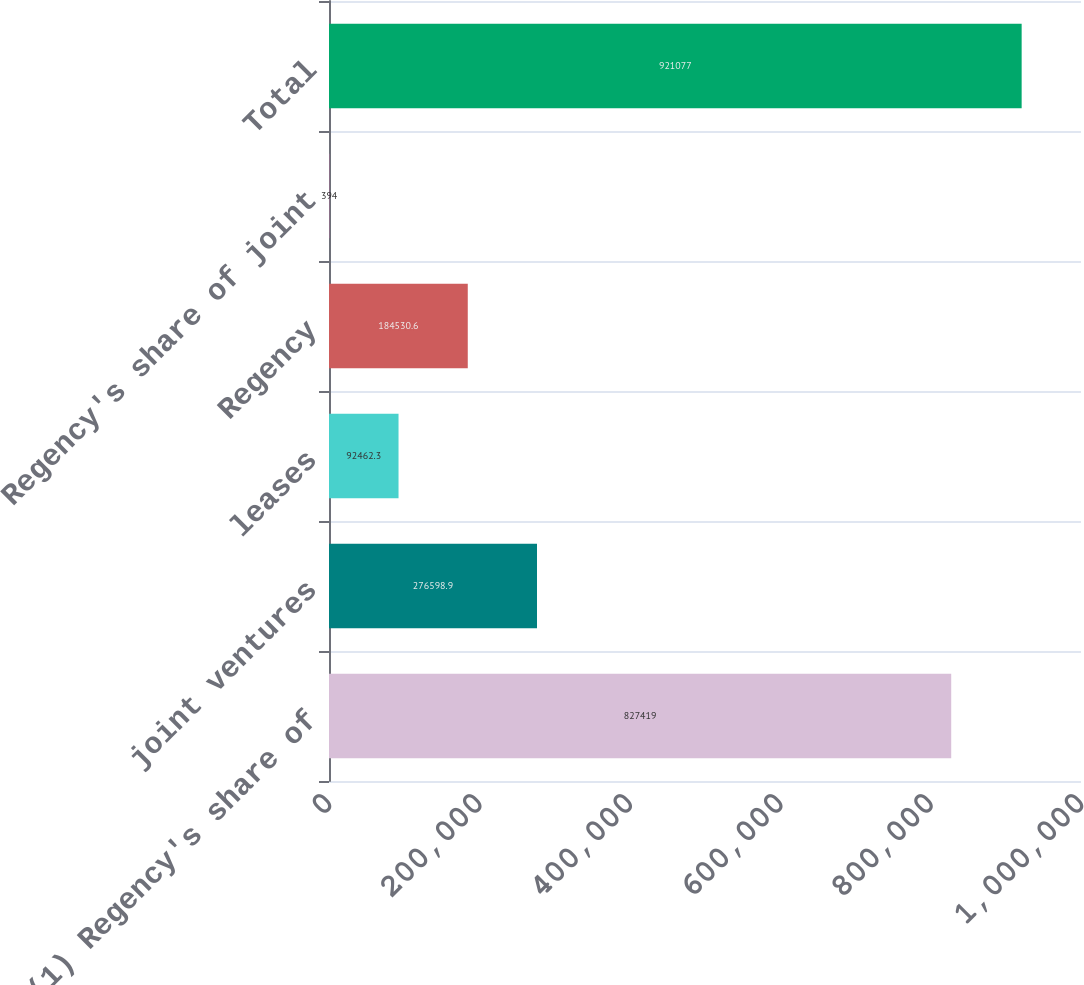Convert chart to OTSL. <chart><loc_0><loc_0><loc_500><loc_500><bar_chart><fcel>Regency (1) Regency's share of<fcel>joint ventures<fcel>leases<fcel>Regency<fcel>Regency's share of joint<fcel>Total<nl><fcel>827419<fcel>276599<fcel>92462.3<fcel>184531<fcel>394<fcel>921077<nl></chart> 